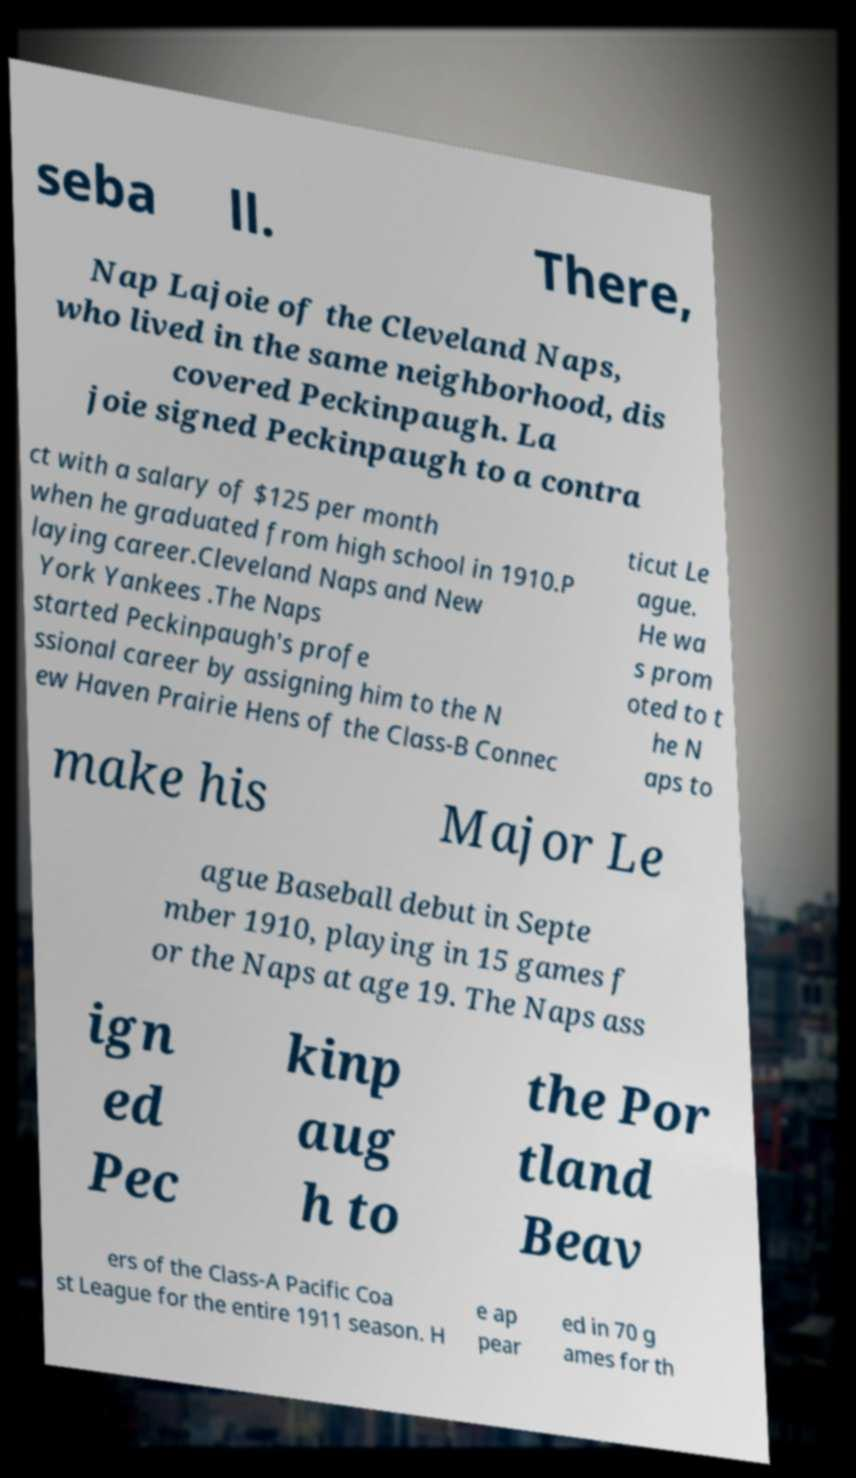Can you accurately transcribe the text from the provided image for me? seba ll. There, Nap Lajoie of the Cleveland Naps, who lived in the same neighborhood, dis covered Peckinpaugh. La joie signed Peckinpaugh to a contra ct with a salary of $125 per month when he graduated from high school in 1910.P laying career.Cleveland Naps and New York Yankees .The Naps started Peckinpaugh's profe ssional career by assigning him to the N ew Haven Prairie Hens of the Class-B Connec ticut Le ague. He wa s prom oted to t he N aps to make his Major Le ague Baseball debut in Septe mber 1910, playing in 15 games f or the Naps at age 19. The Naps ass ign ed Pec kinp aug h to the Por tland Beav ers of the Class-A Pacific Coa st League for the entire 1911 season. H e ap pear ed in 70 g ames for th 